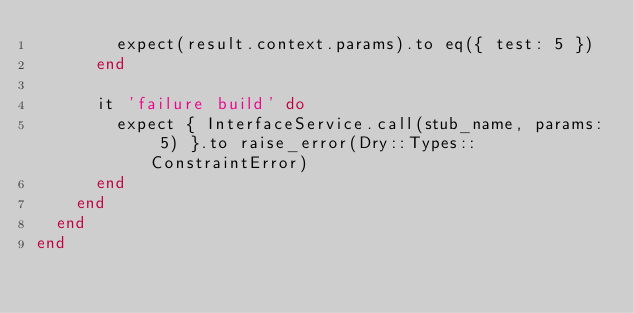Convert code to text. <code><loc_0><loc_0><loc_500><loc_500><_Ruby_>        expect(result.context.params).to eq({ test: 5 })
      end

      it 'failure build' do
        expect { InterfaceService.call(stub_name, params: 5) }.to raise_error(Dry::Types::ConstraintError)
      end
    end
  end
end
</code> 